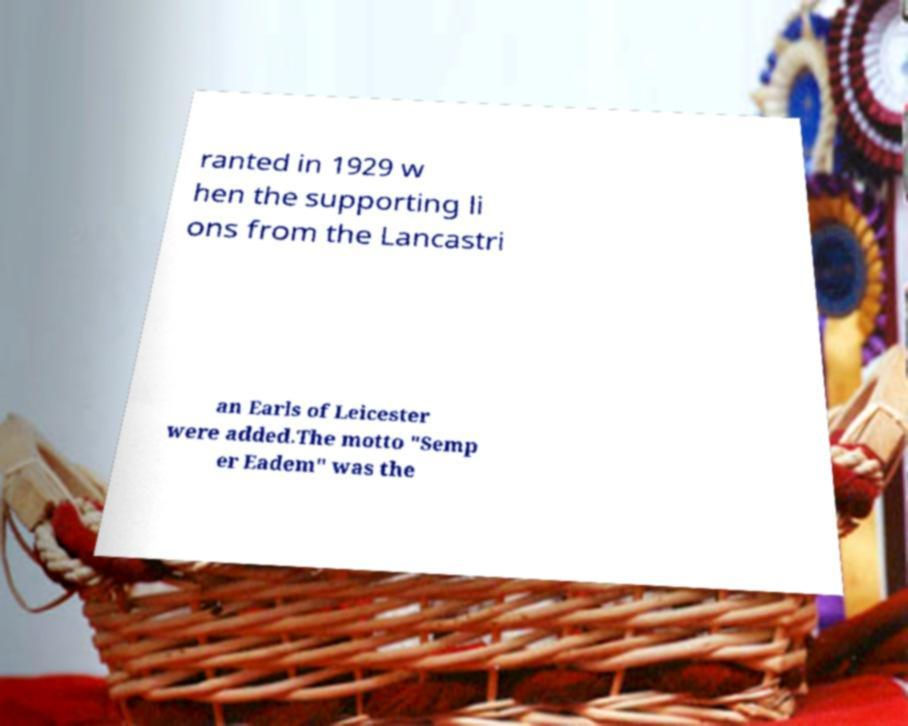Could you extract and type out the text from this image? ranted in 1929 w hen the supporting li ons from the Lancastri an Earls of Leicester were added.The motto "Semp er Eadem" was the 